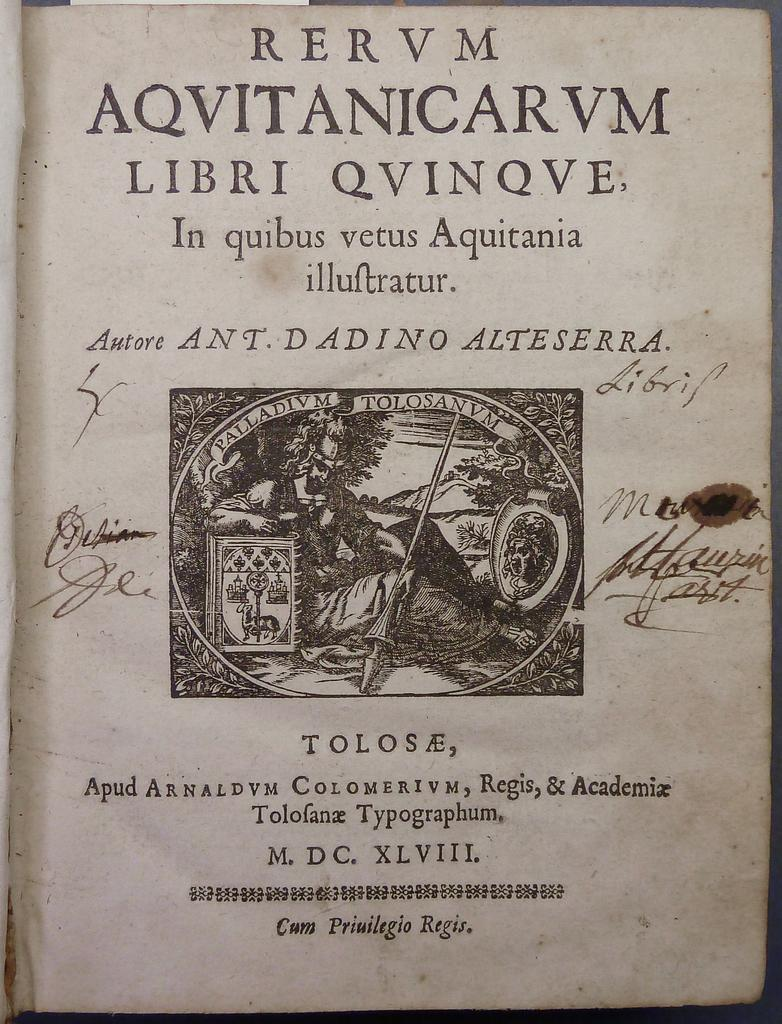<image>
Describe the image concisely. A an old book is called Rervm Aqvitanicarvm Libri Qvinqve. 